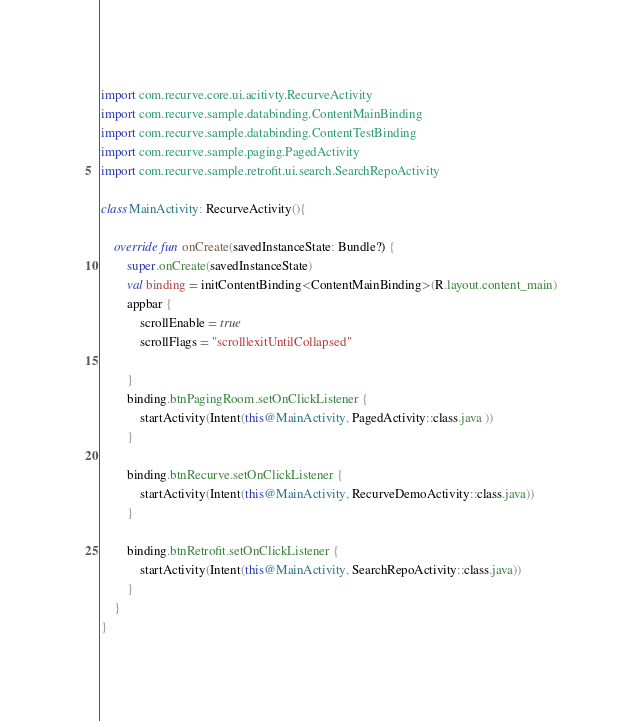<code> <loc_0><loc_0><loc_500><loc_500><_Kotlin_>import com.recurve.core.ui.acitivty.RecurveActivity
import com.recurve.sample.databinding.ContentMainBinding
import com.recurve.sample.databinding.ContentTestBinding
import com.recurve.sample.paging.PagedActivity
import com.recurve.sample.retrofit.ui.search.SearchRepoActivity

class MainActivity: RecurveActivity(){

    override fun onCreate(savedInstanceState: Bundle?) {
        super.onCreate(savedInstanceState)
        val binding = initContentBinding<ContentMainBinding>(R.layout.content_main)
        appbar {
            scrollEnable = true
            scrollFlags = "scroll|exitUntilCollapsed"

        }
        binding.btnPagingRoom.setOnClickListener {
            startActivity(Intent(this@MainActivity, PagedActivity::class.java ))
        }

        binding.btnRecurve.setOnClickListener {
            startActivity(Intent(this@MainActivity, RecurveDemoActivity::class.java))
        }

        binding.btnRetrofit.setOnClickListener {
            startActivity(Intent(this@MainActivity, SearchRepoActivity::class.java))
        }
    }
}</code> 